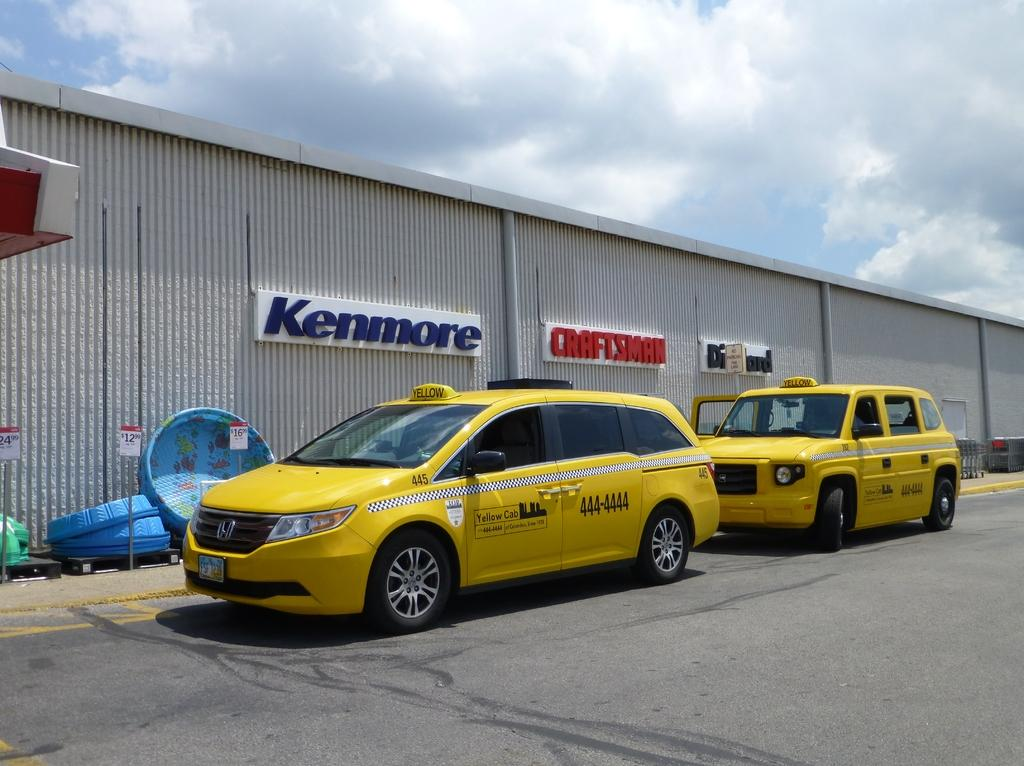<image>
Create a compact narrative representing the image presented. Two taxis are parked outside a building for Kenmore and Craftsman. 